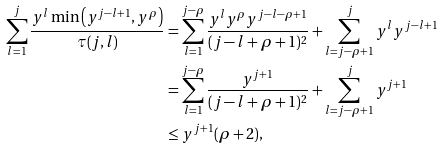Convert formula to latex. <formula><loc_0><loc_0><loc_500><loc_500>\sum _ { l = 1 } ^ { j } \frac { y ^ { l } \min \left ( y ^ { j - l + 1 } , y ^ { \rho } \right ) } { \tau ( j , l ) } & = \sum _ { l = 1 } ^ { j - \rho } \frac { y ^ { l } y ^ { \rho } y ^ { j - l - \rho + 1 } } { ( j - l + \rho + 1 ) ^ { 2 } } + \sum _ { l = j - \rho + 1 } ^ { j } y ^ { l } y ^ { j - l + 1 } \\ & = \sum _ { l = 1 } ^ { j - \rho } \frac { y ^ { j + 1 } } { ( j - l + \rho + 1 ) ^ { 2 } } + \sum _ { l = j - \rho + 1 } ^ { j } y ^ { j + 1 } \\ & \leq y ^ { j + 1 } ( \rho + 2 ) ,</formula> 